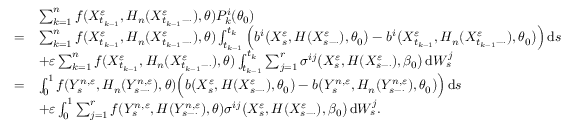Convert formula to latex. <formula><loc_0><loc_0><loc_500><loc_500>\begin{array} { r l } & { \sum _ { k = 1 } ^ { n } f ( X _ { t _ { k - 1 } } ^ { \varepsilon } , H _ { n } ( X _ { t _ { k - 1 } - \cdot } ^ { \varepsilon } ) , \theta ) P _ { k } ^ { i } ( \theta _ { 0 } ) } \\ { = } & { \sum _ { k = 1 } ^ { n } f ( X _ { t _ { k - 1 } } ^ { \varepsilon } , H _ { n } ( X _ { t _ { k - 1 } - \cdot } ^ { \varepsilon } ) , \theta ) \int _ { t _ { k - 1 } } ^ { t _ { k } } \left ( b ^ { i } \left ( X _ { s } ^ { \varepsilon } , H ( X _ { s - \cdot } ^ { \varepsilon } ) , \theta _ { 0 } \right ) - b ^ { i } \left ( X _ { t _ { k - 1 } } ^ { \varepsilon } , H _ { n } ( X _ { t _ { k - 1 } - \cdot } ^ { \varepsilon } ) , \theta _ { 0 } \right ) \right ) \, d s } \\ & { + \varepsilon \sum _ { k = 1 } ^ { n } f ( X _ { t _ { k - 1 } } ^ { \varepsilon } , H _ { n } ( X _ { t _ { k - 1 } - \cdot } ^ { \varepsilon } ) , \theta ) \int _ { t _ { k - 1 } } ^ { t _ { k } } \sum _ { j = 1 } ^ { r } \sigma ^ { i j } \left ( X _ { s } ^ { \varepsilon } , H ( X _ { s - \cdot } ^ { \varepsilon } ) , \beta _ { 0 } \right ) \, d W _ { s } ^ { j } } \\ { = } & { \int _ { 0 } ^ { 1 } f ( Y _ { s } ^ { n , \varepsilon } , H _ { n } ( Y _ { s - \cdot } ^ { n , \varepsilon } ) , \theta ) \left ( b \left ( X _ { s } ^ { \varepsilon } , H ( X _ { s - \cdot } ^ { \varepsilon } ) , \theta _ { 0 } \right ) - b \left ( Y _ { s } ^ { n , \varepsilon } , H _ { n } ( Y _ { s - \cdot } ^ { n , \varepsilon } ) , \theta _ { 0 } \right ) \right ) \, d s } \\ & { + \varepsilon \int _ { 0 } ^ { 1 } \sum _ { j = 1 } ^ { r } f ( Y _ { s } ^ { n , \varepsilon } , H ( Y _ { s - \cdot } ^ { n , \varepsilon } ) , \theta ) \sigma ^ { i j } \left ( X _ { s } ^ { \varepsilon } , H ( X _ { s - \cdot } ^ { \varepsilon } ) , \beta _ { 0 } \right ) \, d W _ { s } ^ { j } . } \end{array}</formula> 